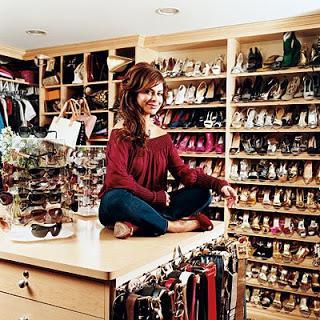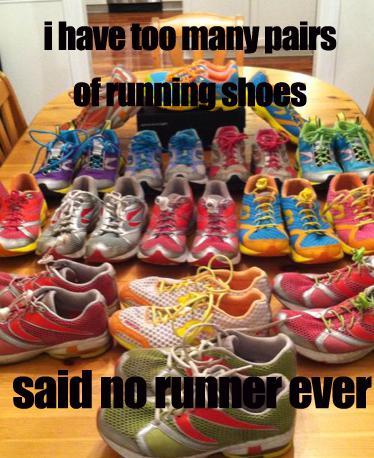The first image is the image on the left, the second image is the image on the right. Examine the images to the left and right. Is the description "One image shows several pairs of shoes lined up neatly on the floor." accurate? Answer yes or no. No. The first image is the image on the left, the second image is the image on the right. Assess this claim about the two images: "The left image shows many shoes arranged in rows on shelves.". Correct or not? Answer yes or no. Yes. 